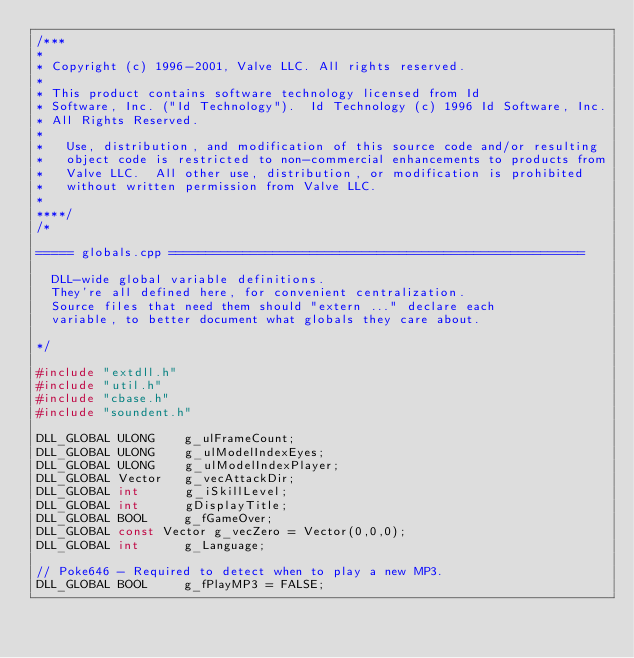Convert code to text. <code><loc_0><loc_0><loc_500><loc_500><_C++_>/***
*
*	Copyright (c) 1996-2001, Valve LLC. All rights reserved.
*	
*	This product contains software technology licensed from Id 
*	Software, Inc. ("Id Technology").  Id Technology (c) 1996 Id Software, Inc. 
*	All Rights Reserved.
*
*   Use, distribution, and modification of this source code and/or resulting
*   object code is restricted to non-commercial enhancements to products from
*   Valve LLC.  All other use, distribution, or modification is prohibited
*   without written permission from Valve LLC.
*
****/
/*

===== globals.cpp ========================================================

  DLL-wide global variable definitions.
  They're all defined here, for convenient centralization.
  Source files that need them should "extern ..." declare each
  variable, to better document what globals they care about.

*/

#include "extdll.h"
#include "util.h"
#include "cbase.h"
#include "soundent.h"

DLL_GLOBAL ULONG		g_ulFrameCount;
DLL_GLOBAL ULONG		g_ulModelIndexEyes;
DLL_GLOBAL ULONG		g_ulModelIndexPlayer;
DLL_GLOBAL Vector		g_vecAttackDir;
DLL_GLOBAL int			g_iSkillLevel;
DLL_GLOBAL int			gDisplayTitle;
DLL_GLOBAL BOOL			g_fGameOver;
DLL_GLOBAL const Vector	g_vecZero = Vector(0,0,0);
DLL_GLOBAL int			g_Language;

// Poke646 - Required to detect when to play a new MP3.
DLL_GLOBAL BOOL			g_fPlayMP3 = FALSE;
</code> 